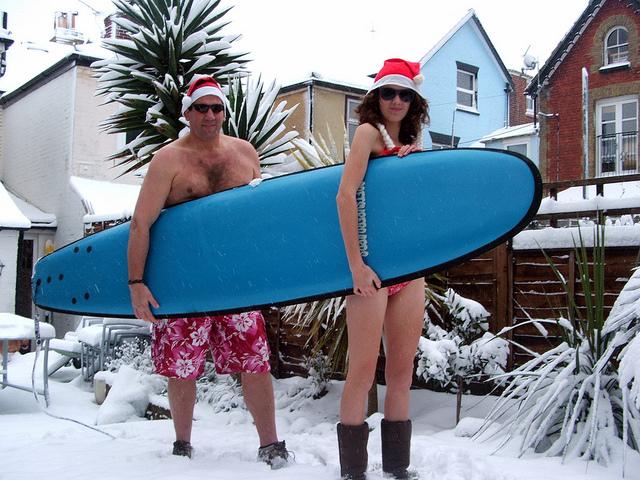What color is the surfboard?
Concise answer only. Blue. Is it summer?
Concise answer only. No. What is missing here?
Concise answer only. Clothes. 